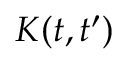<formula> <loc_0><loc_0><loc_500><loc_500>K ( t , t ^ { \prime } )</formula> 